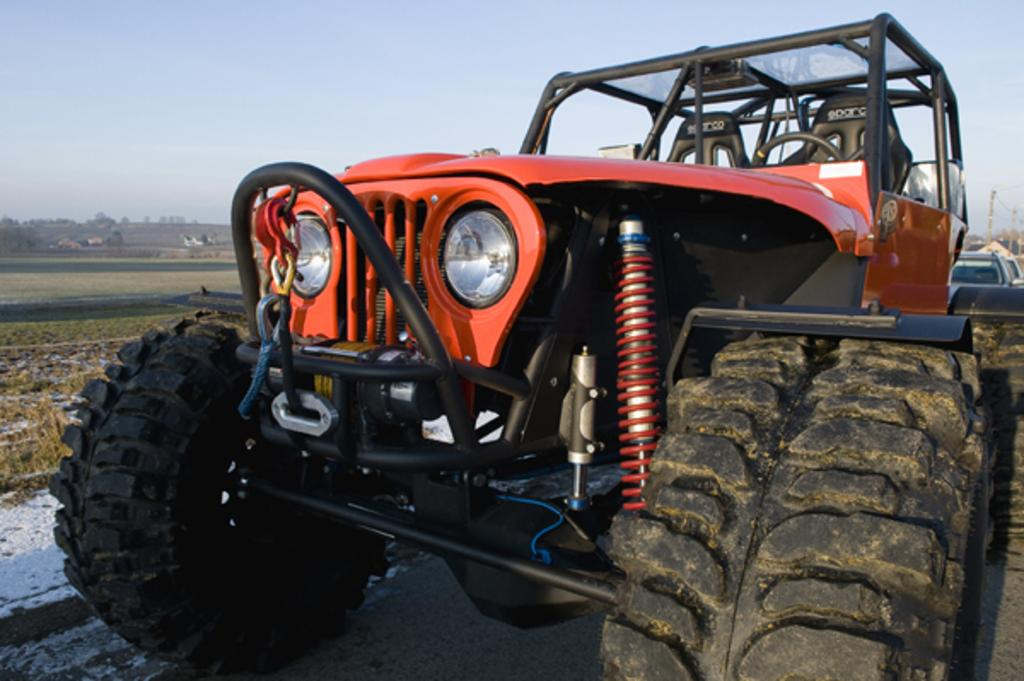What can be seen on the road in the image? There are vehicles on the road in the image. What type of vegetation is visible in the image? There is grass visible in the image, as well as trees. What structures can be seen in the image? There are poles in the image. What else is present in the image besides the vehicles, grass, trees, and poles? There are some objects in the image. What is visible in the background of the image? The sky is visible in the background of the image. Can you see a lake in the image? There is no lake present in the image. Is there a throne visible in the image? There is no throne present in the image. 